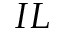<formula> <loc_0><loc_0><loc_500><loc_500>I L</formula> 